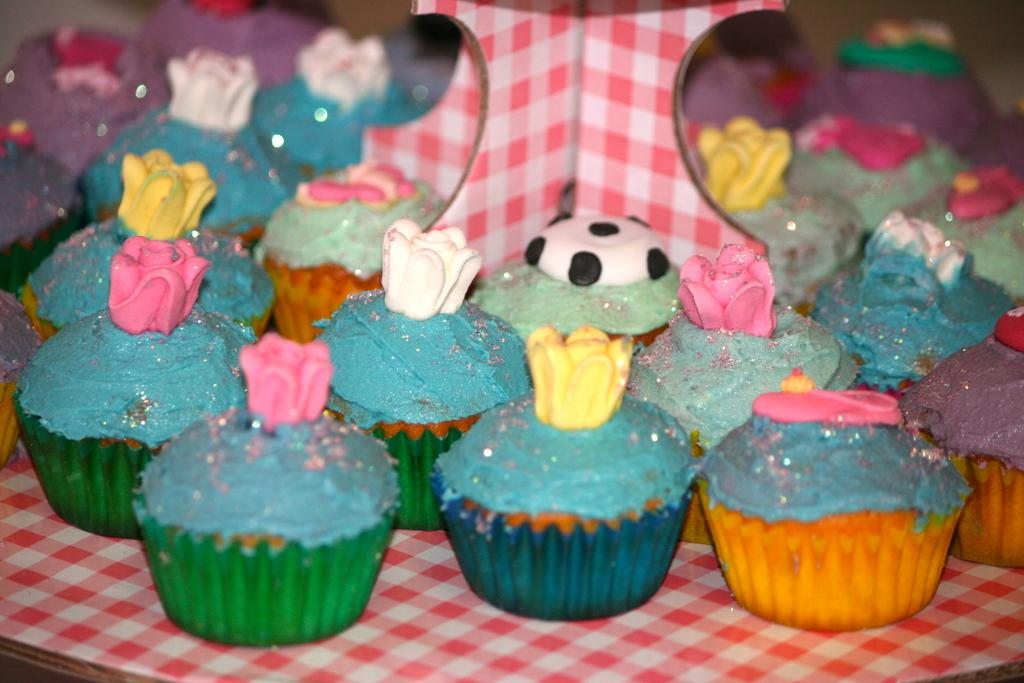What type of food can be seen in the image? There are cupcakes in the image. What is the surface at the bottom of the image made of? The surface at the bottom of the image is made of wood. How many giraffes can be seen on the island in the image? There are no giraffes or islands present in the image; it features cupcakes on a wooden surface. 